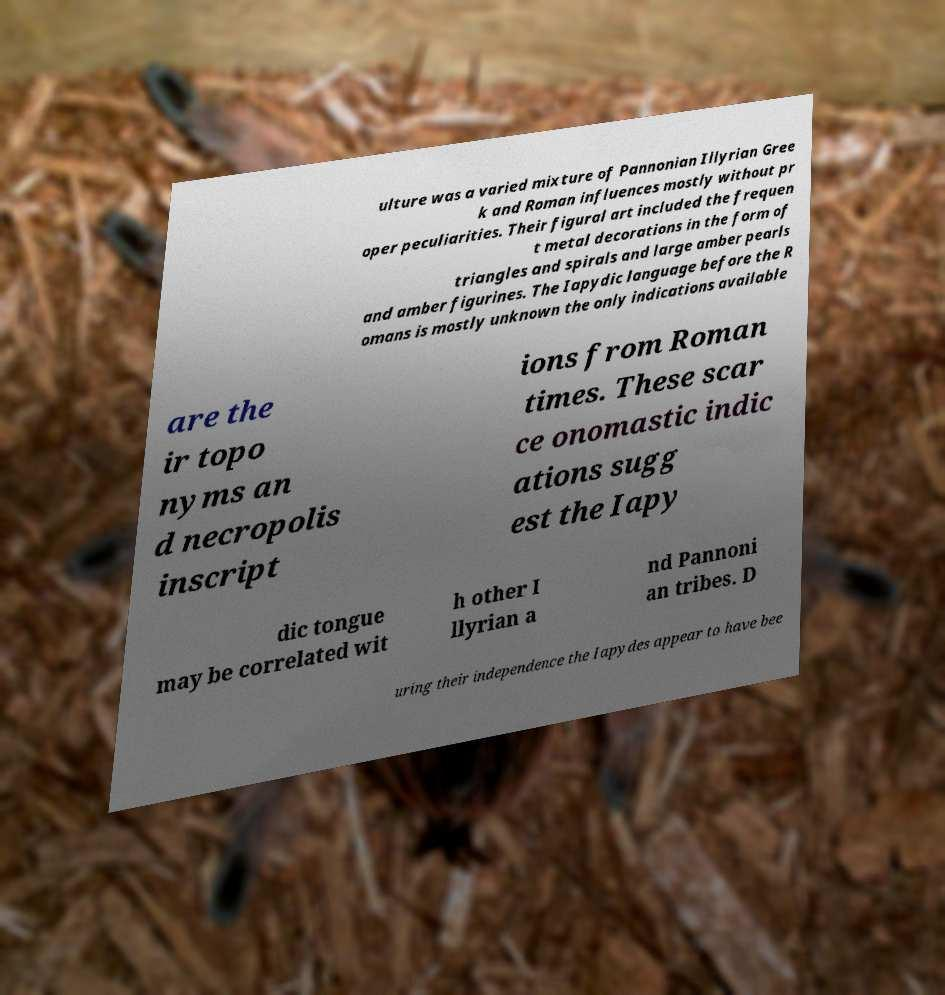There's text embedded in this image that I need extracted. Can you transcribe it verbatim? ulture was a varied mixture of Pannonian Illyrian Gree k and Roman influences mostly without pr oper peculiarities. Their figural art included the frequen t metal decorations in the form of triangles and spirals and large amber pearls and amber figurines. The Iapydic language before the R omans is mostly unknown the only indications available are the ir topo nyms an d necropolis inscript ions from Roman times. These scar ce onomastic indic ations sugg est the Iapy dic tongue may be correlated wit h other I llyrian a nd Pannoni an tribes. D uring their independence the Iapydes appear to have bee 